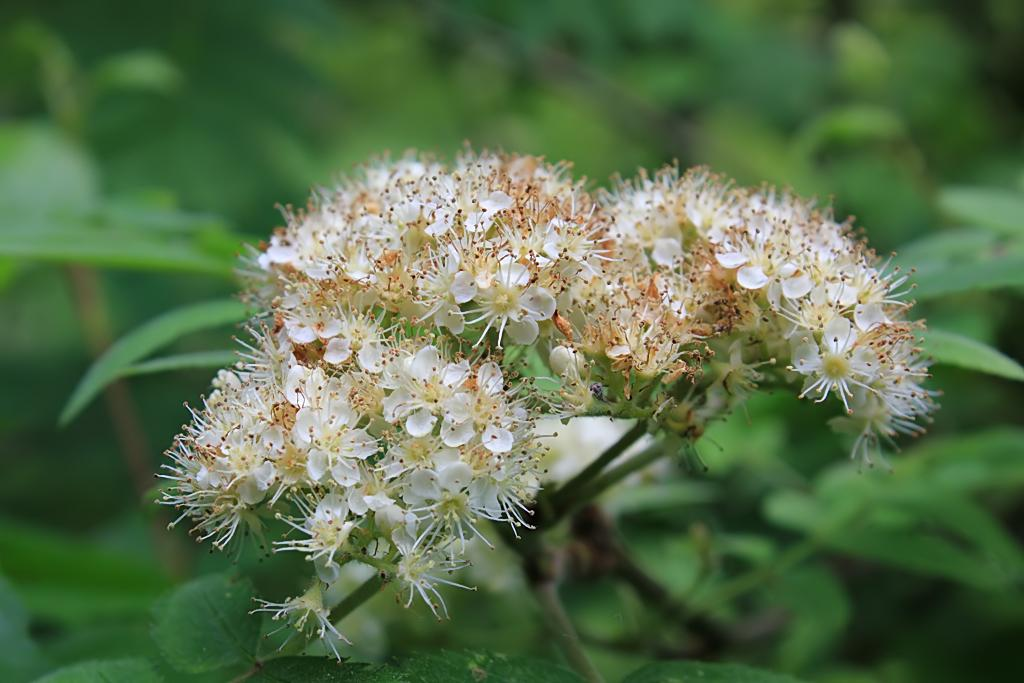What type of living organisms can be seen in the image? There are flowers in the image. Can you describe the background of the image? The background of the image is blurred. What type of cheese is being served on the street in the image? There is no cheese or street present in the image; it features flowers with a blurred background. 